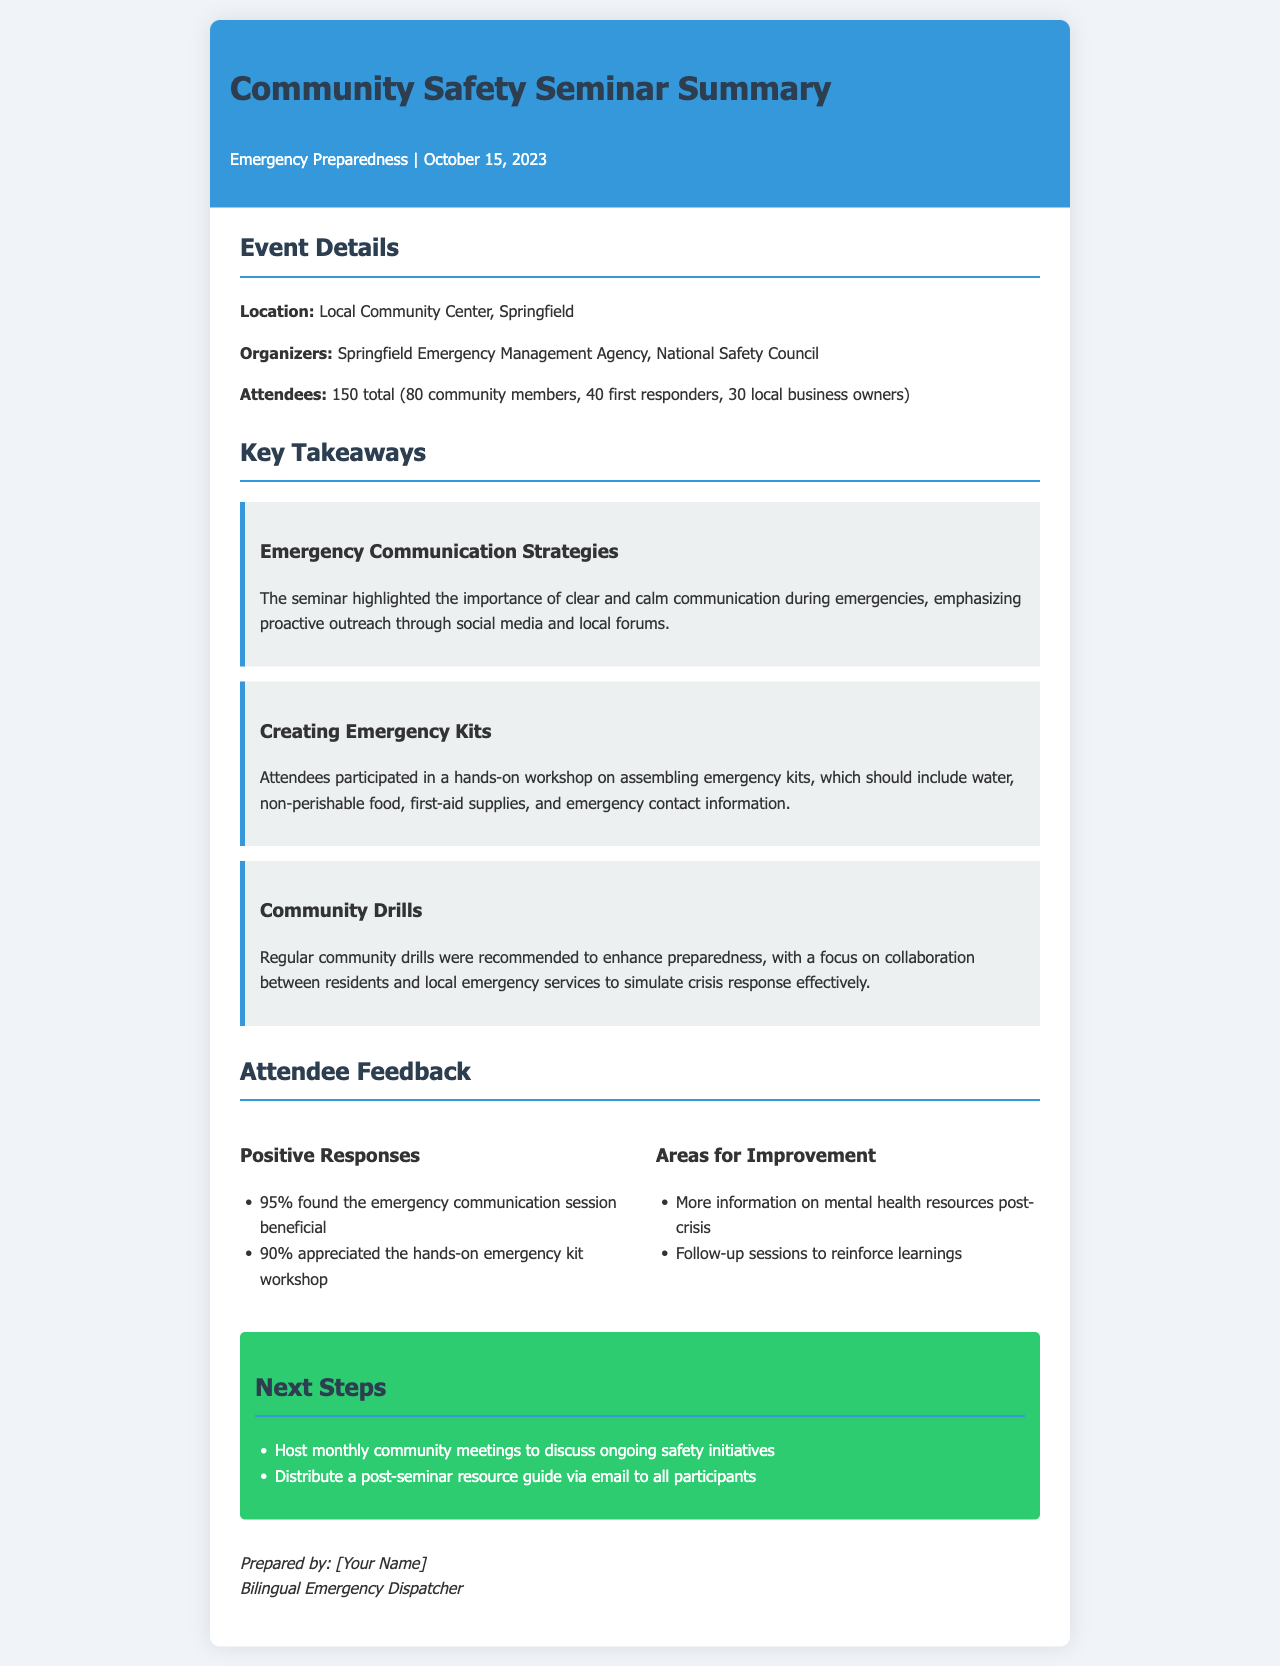What date was the seminar held? The date of the seminar is specified in the document as October 15, 2023.
Answer: October 15, 2023 How many community members attended? The document mentions that there were 80 community members present at the seminar.
Answer: 80 What percentage found the emergency communication session beneficial? According to the feedback section, 95% of attendees found that session beneficial.
Answer: 95% What was a recommended next step from the seminar? The document lists hosting monthly community meetings as a recommended next step.
Answer: Host monthly community meetings How many total attendees were there? The total number of attendees is the sum of community members, first responders, and local business owners, which totals 150.
Answer: 150 What type of workshop did attendees participate in? The document states that attendees participated in a hands-on workshop focused on assembling emergency kits.
Answer: Assembling emergency kits What is the title of the seminar? The title of the seminar, as mentioned in the document, is "Community Safety Seminar Summary."
Answer: Community Safety Seminar Summary What was one area for improvement mentioned? One area for improvement identified in the feedback was more information on mental health resources post-crisis.
Answer: More information on mental health resources post-crisis Who organized the seminar? The document indicates that the seminar was organized by the Springfield Emergency Management Agency and the National Safety Council.
Answer: Springfield Emergency Management Agency, National Safety Council 